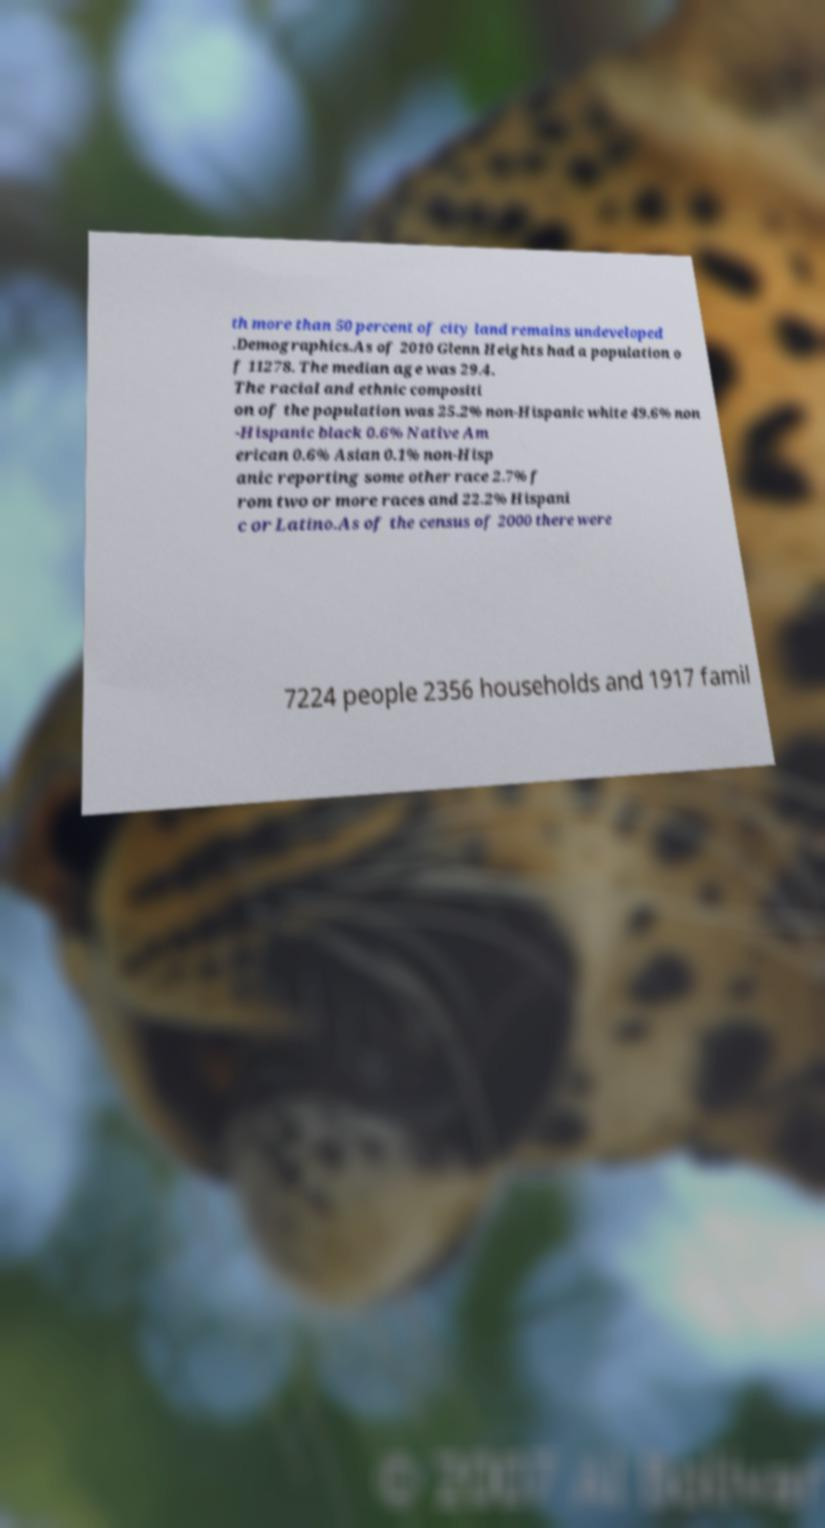What messages or text are displayed in this image? I need them in a readable, typed format. th more than 50 percent of city land remains undeveloped .Demographics.As of 2010 Glenn Heights had a population o f 11278. The median age was 29.4. The racial and ethnic compositi on of the population was 25.2% non-Hispanic white 49.6% non -Hispanic black 0.6% Native Am erican 0.6% Asian 0.1% non-Hisp anic reporting some other race 2.7% f rom two or more races and 22.2% Hispani c or Latino.As of the census of 2000 there were 7224 people 2356 households and 1917 famil 